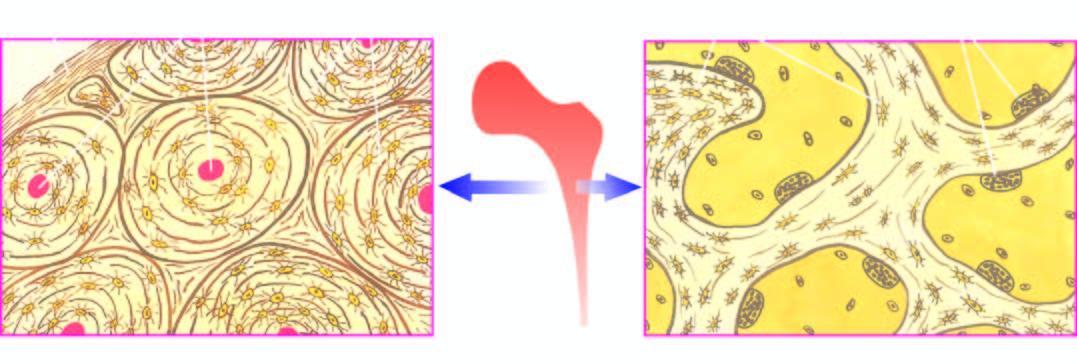what shows concentric lamellae along with osteocytic lacunae surrounding central blood vessels, while the trabecular bone forming the marrow space shows trabeculae with osteoclastic activity at the margins?
Answer the question using a single word or phrase. Cortical bone forming the outer shell 